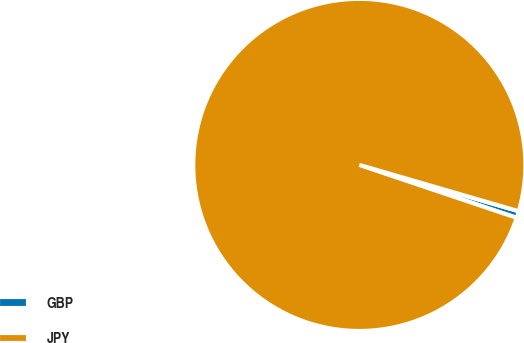Convert chart. <chart><loc_0><loc_0><loc_500><loc_500><pie_chart><fcel>GBP<fcel>JPY<nl><fcel>0.66%<fcel>99.34%<nl></chart> 